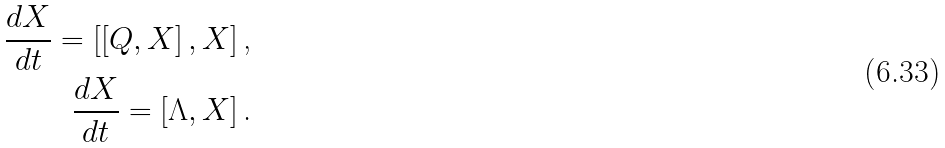Convert formula to latex. <formula><loc_0><loc_0><loc_500><loc_500>\frac { d X } { d t } = \left [ \left [ Q , X \right ] , X \right ] \text {,} \\ \frac { d X } { d t } = \left [ \Lambda , X \right ] \text {.}</formula> 